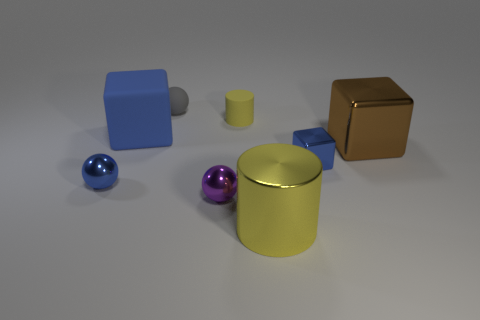Is the size of the ball behind the big brown metal block the same as the rubber object that is left of the gray matte ball?
Offer a terse response. No. What number of other tiny blue objects have the same shape as the blue matte thing?
Ensure brevity in your answer.  1. There is a rubber sphere that is to the left of the tiny blue block; what size is it?
Your response must be concise. Small. The large thing that is the same material as the big yellow cylinder is what shape?
Your answer should be compact. Cube. Is the large yellow object made of the same material as the blue object on the left side of the rubber cube?
Your answer should be compact. Yes. Do the blue thing on the right side of the rubber cylinder and the brown shiny object have the same shape?
Offer a very short reply. Yes. What is the material of the other thing that is the same shape as the yellow shiny thing?
Offer a very short reply. Rubber. Does the purple thing have the same shape as the small blue thing that is on the right side of the big yellow cylinder?
Your response must be concise. No. What color is the tiny ball that is in front of the big metallic block and behind the tiny purple thing?
Make the answer very short. Blue. Are any large yellow metal cubes visible?
Your answer should be compact. No. 